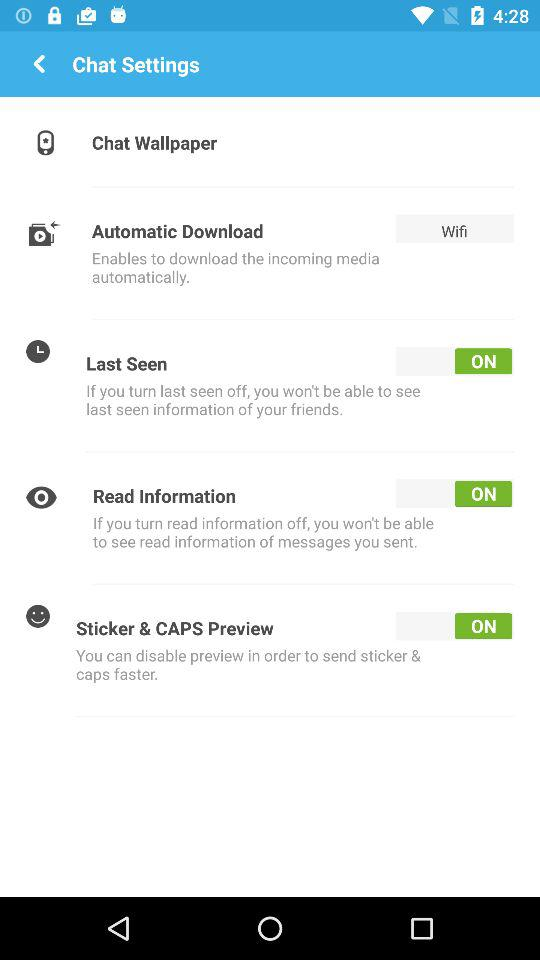What is the current status of the "Sticker & CAPS Preview"? The current status is "on". 